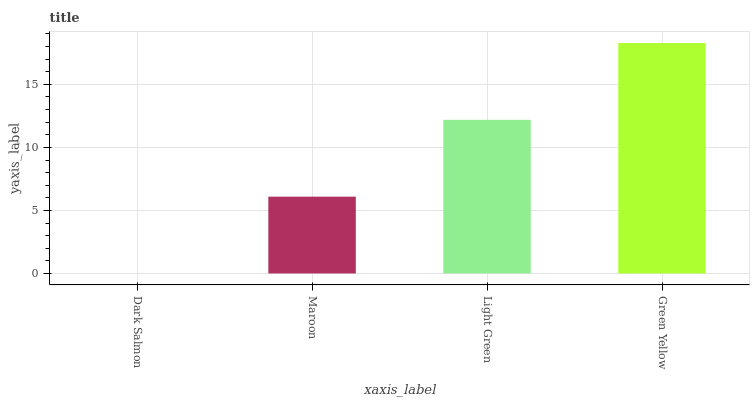Is Maroon the minimum?
Answer yes or no. No. Is Maroon the maximum?
Answer yes or no. No. Is Maroon greater than Dark Salmon?
Answer yes or no. Yes. Is Dark Salmon less than Maroon?
Answer yes or no. Yes. Is Dark Salmon greater than Maroon?
Answer yes or no. No. Is Maroon less than Dark Salmon?
Answer yes or no. No. Is Light Green the high median?
Answer yes or no. Yes. Is Maroon the low median?
Answer yes or no. Yes. Is Green Yellow the high median?
Answer yes or no. No. Is Light Green the low median?
Answer yes or no. No. 